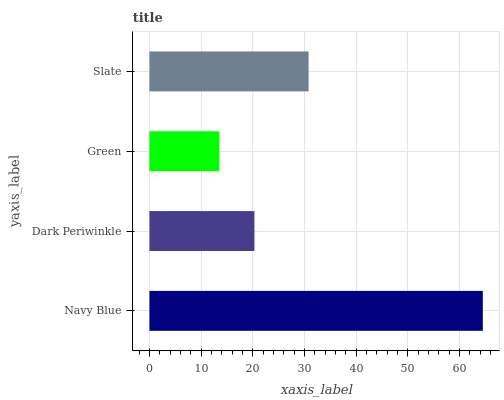Is Green the minimum?
Answer yes or no. Yes. Is Navy Blue the maximum?
Answer yes or no. Yes. Is Dark Periwinkle the minimum?
Answer yes or no. No. Is Dark Periwinkle the maximum?
Answer yes or no. No. Is Navy Blue greater than Dark Periwinkle?
Answer yes or no. Yes. Is Dark Periwinkle less than Navy Blue?
Answer yes or no. Yes. Is Dark Periwinkle greater than Navy Blue?
Answer yes or no. No. Is Navy Blue less than Dark Periwinkle?
Answer yes or no. No. Is Slate the high median?
Answer yes or no. Yes. Is Dark Periwinkle the low median?
Answer yes or no. Yes. Is Dark Periwinkle the high median?
Answer yes or no. No. Is Slate the low median?
Answer yes or no. No. 